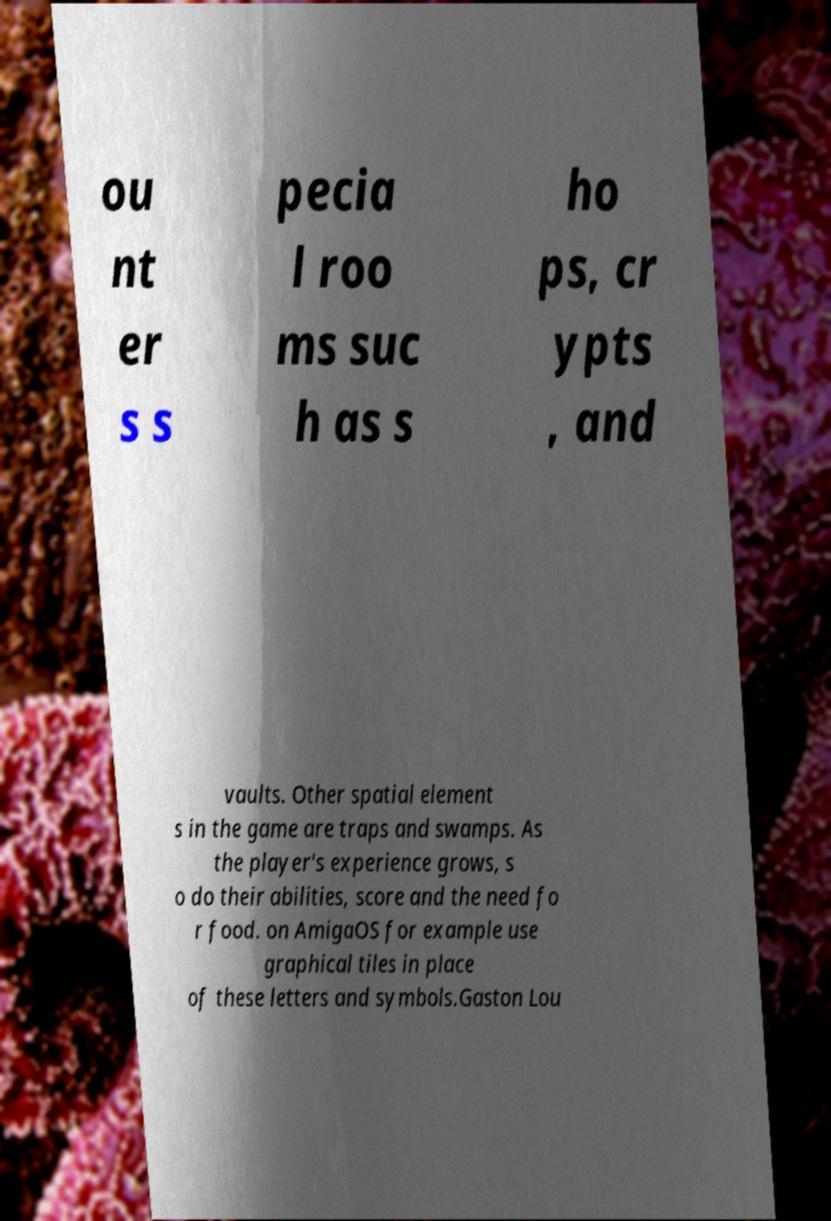Please identify and transcribe the text found in this image. ou nt er s s pecia l roo ms suc h as s ho ps, cr ypts , and vaults. Other spatial element s in the game are traps and swamps. As the player's experience grows, s o do their abilities, score and the need fo r food. on AmigaOS for example use graphical tiles in place of these letters and symbols.Gaston Lou 